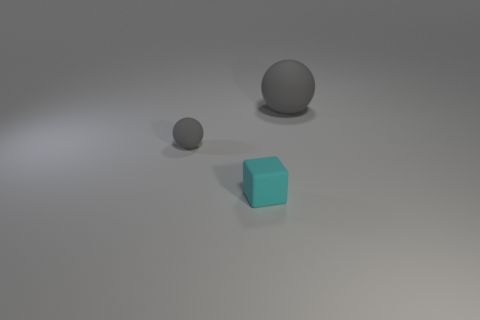Add 2 tiny cubes. How many objects exist? 5 Add 2 tiny matte spheres. How many tiny matte spheres are left? 3 Add 1 small brown cubes. How many small brown cubes exist? 1 Subtract 0 purple blocks. How many objects are left? 3 Subtract all balls. How many objects are left? 1 Subtract 1 blocks. How many blocks are left? 0 Subtract all yellow balls. Subtract all green cubes. How many balls are left? 2 Subtract all purple spheres. How many green blocks are left? 0 Subtract all purple matte blocks. Subtract all tiny spheres. How many objects are left? 2 